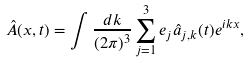Convert formula to latex. <formula><loc_0><loc_0><loc_500><loc_500>\hat { A } ( { x } , t ) = \int \frac { d { k } } { ( 2 \pi ) ^ { 3 } } \sum _ { j = 1 } ^ { 3 } { e } _ { j } \hat { a } _ { j , { k } } ( t ) e ^ { i { k x } } ,</formula> 